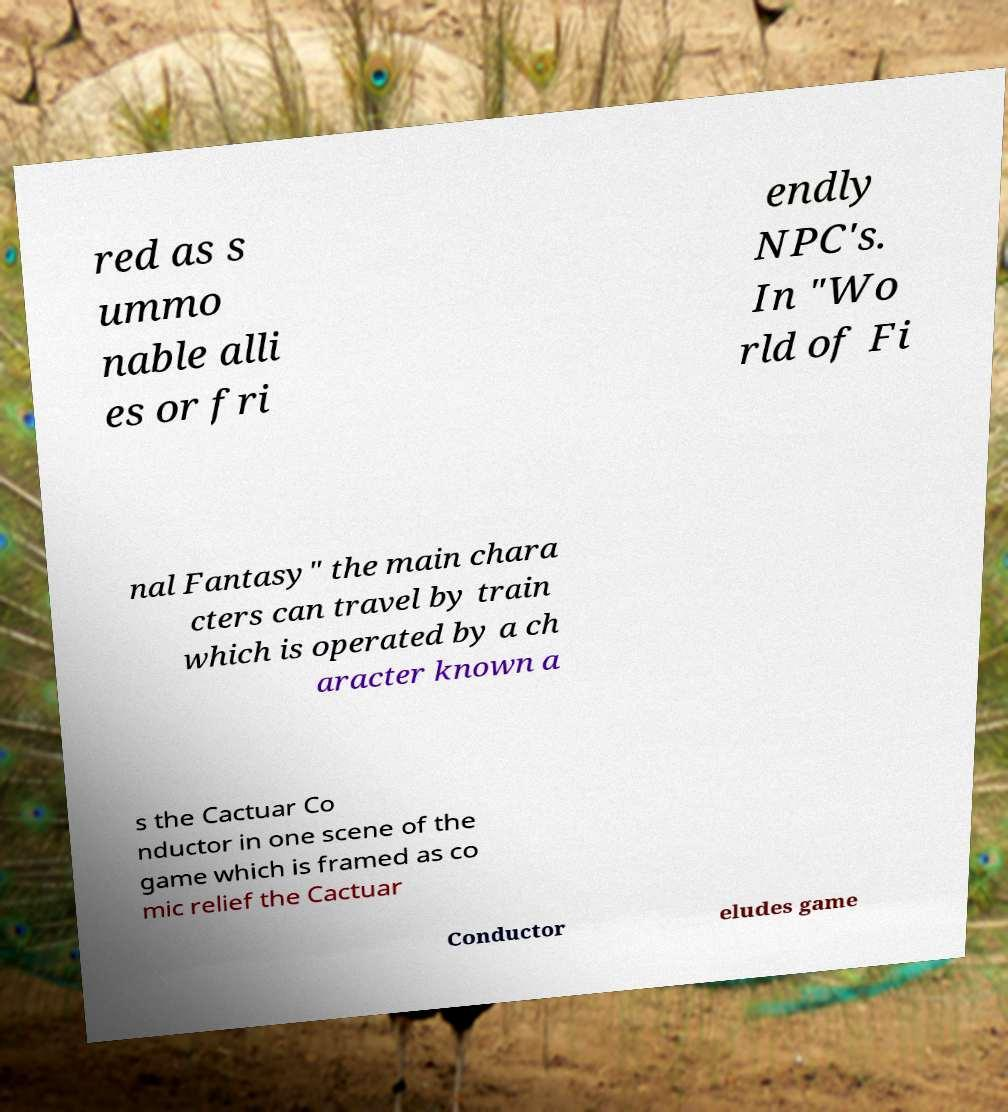Can you accurately transcribe the text from the provided image for me? red as s ummo nable alli es or fri endly NPC's. In "Wo rld of Fi nal Fantasy" the main chara cters can travel by train which is operated by a ch aracter known a s the Cactuar Co nductor in one scene of the game which is framed as co mic relief the Cactuar Conductor eludes game 